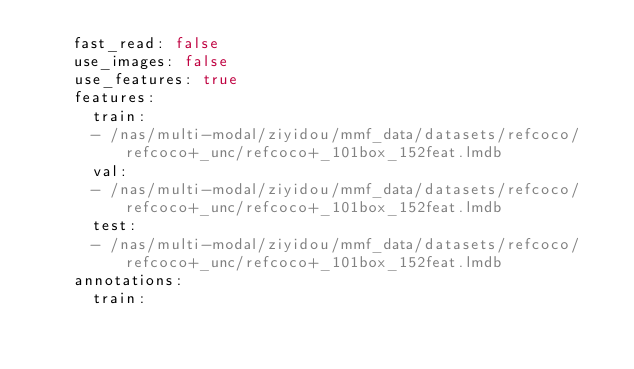Convert code to text. <code><loc_0><loc_0><loc_500><loc_500><_YAML_>    fast_read: false
    use_images: false
    use_features: true
    features:
      train:
      - /nas/multi-modal/ziyidou/mmf_data/datasets/refcoco/refcoco+_unc/refcoco+_101box_152feat.lmdb
      val:
      - /nas/multi-modal/ziyidou/mmf_data/datasets/refcoco/refcoco+_unc/refcoco+_101box_152feat.lmdb
      test:
      - /nas/multi-modal/ziyidou/mmf_data/datasets/refcoco/refcoco+_unc/refcoco+_101box_152feat.lmdb
    annotations:
      train:</code> 